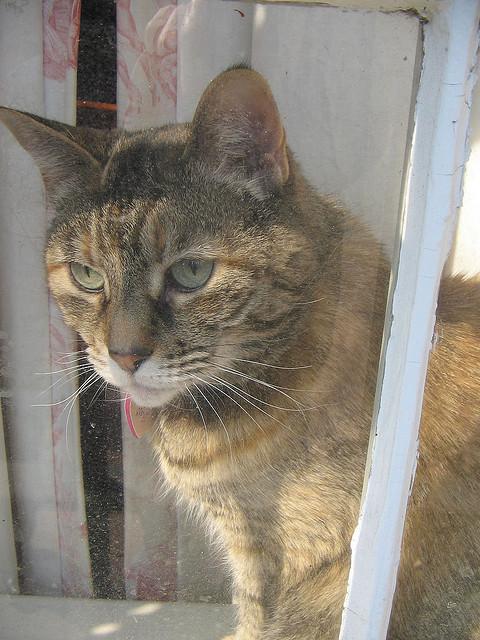What kind of animal is this?
Short answer required. Cat. Is the cat wearing a collar?
Keep it brief. Yes. What colors are the cat?
Short answer required. Orange and black. Does the cat look nice?
Write a very short answer. Yes. Is the cat inside?
Keep it brief. Yes. 